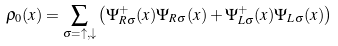<formula> <loc_0><loc_0><loc_500><loc_500>\rho _ { 0 } ( x ) = \sum _ { \sigma = \uparrow , \downarrow } \left ( \Psi ^ { + } _ { R \sigma } ( x ) \Psi _ { R \sigma } ( x ) + \Psi ^ { + } _ { L \sigma } ( x ) \Psi _ { L \sigma } ( x ) \right )</formula> 